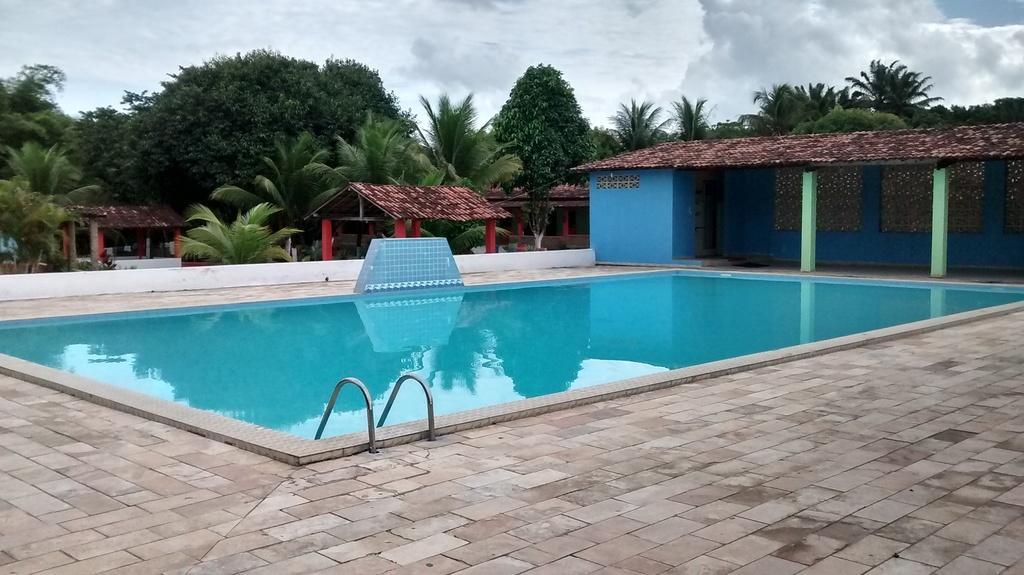Please provide a concise description of this image. In this image there is a swimming pool, huts , trees, and in the background there is sky. 